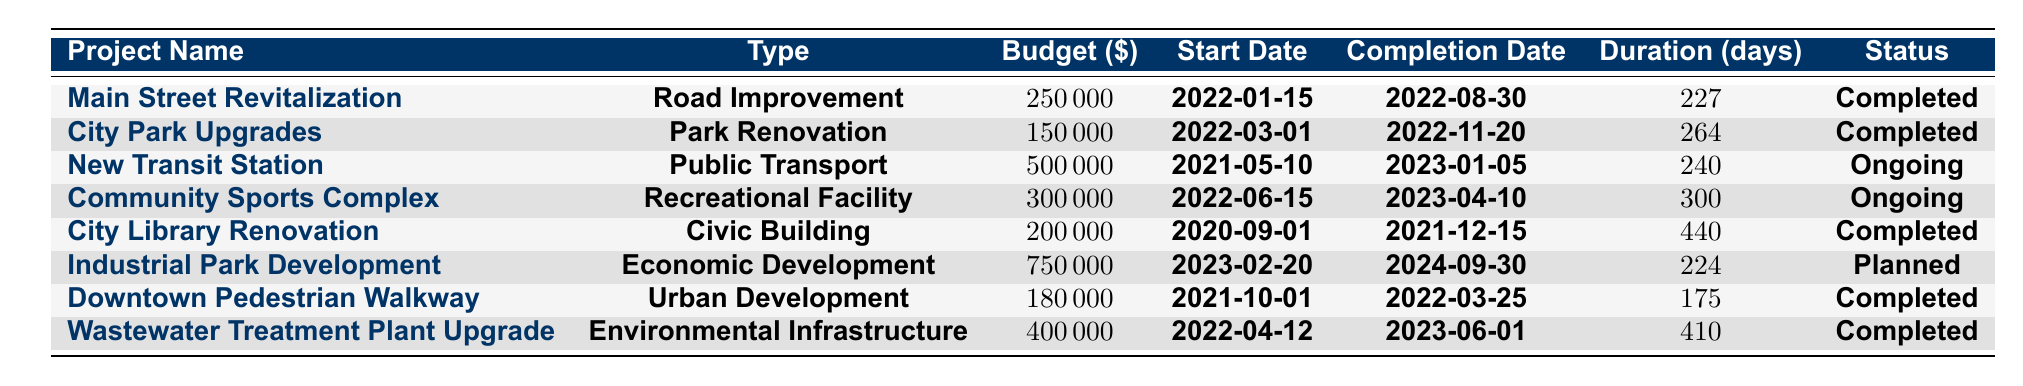What is the budget for the City Park Upgrades project? The budget for the City Park Upgrades project is found in the table under the budget column for that project. The value listed there is 150,000.
Answer: 150,000 Which project has the longest duration? To find the longest duration, look at the duration column for each project and identify the highest value. The City Library Renovation has a duration of 440 days, which is the longest.
Answer: City Library Renovation Is the New Transit Station project completed? The status of the New Transit Station project is listed in the table under the status column. It states "Ongoing," so it is not completed.
Answer: No What is the total budget allocated to the completed projects? Sum the budgets of all projects with a status of "Completed." The budgets for completed projects are 250,000 (Main Street Revitalization) + 150,000 (City Park Upgrades) + 200,000 (City Library Renovation) + 180,000 (Downtown Pedestrian Walkway) + 400,000 (Wastewater Treatment Plant Upgrade), which totals 1,180,000.
Answer: 1,180,000 How many projects are currently ongoing? Count the projects listed in the table that have the status "Ongoing." There are two projects: the New Transit Station and the Community Sports Complex.
Answer: 2 What is the average duration of completed projects? First, identify the durations of the completed projects: 227 (Main Street Revitalization), 264 (City Park Upgrades), 440 (City Library Renovation), 175 (Downtown Pedestrian Walkway), and 410 (Wastewater Treatment Plant Upgrade). The total duration is 227 + 264 + 440 + 175 + 410 = 1516 days. There are 5 completed projects, so the average duration is 1516 / 5 = 303.2 days.
Answer: 303.2 days Which project has the earliest start date? Look through the start dates of all the projects. The earliest date listed is 2020-09-01 for the City Library Renovation.
Answer: City Library Renovation Is there a project type without any completed projects? Examine the project types and check which ones have completed projects. The only type without completed projects is "Economic Development," as its only entry (Industrial Park Development) is marked as "Planned."
Answer: Yes 